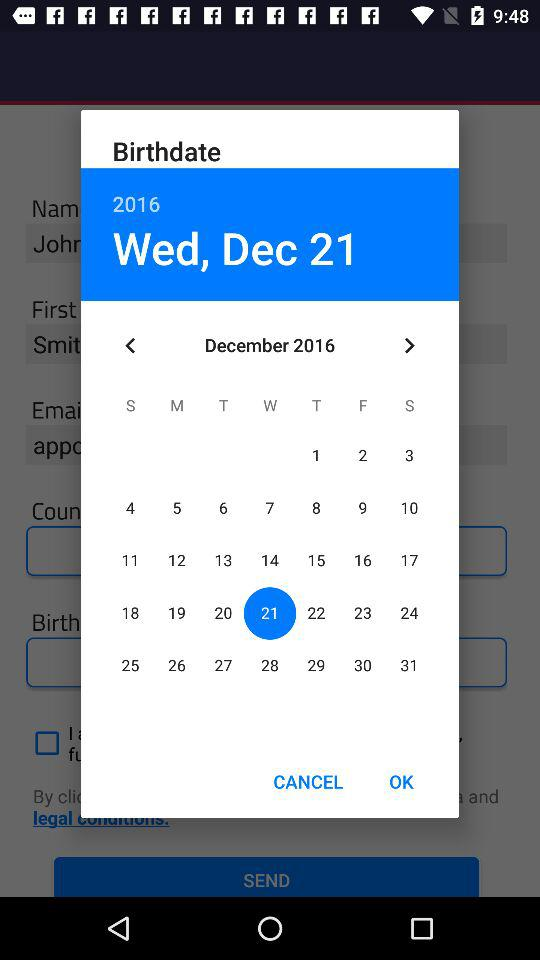Which year is displayed on the calendar? The displayed year is 2016. 